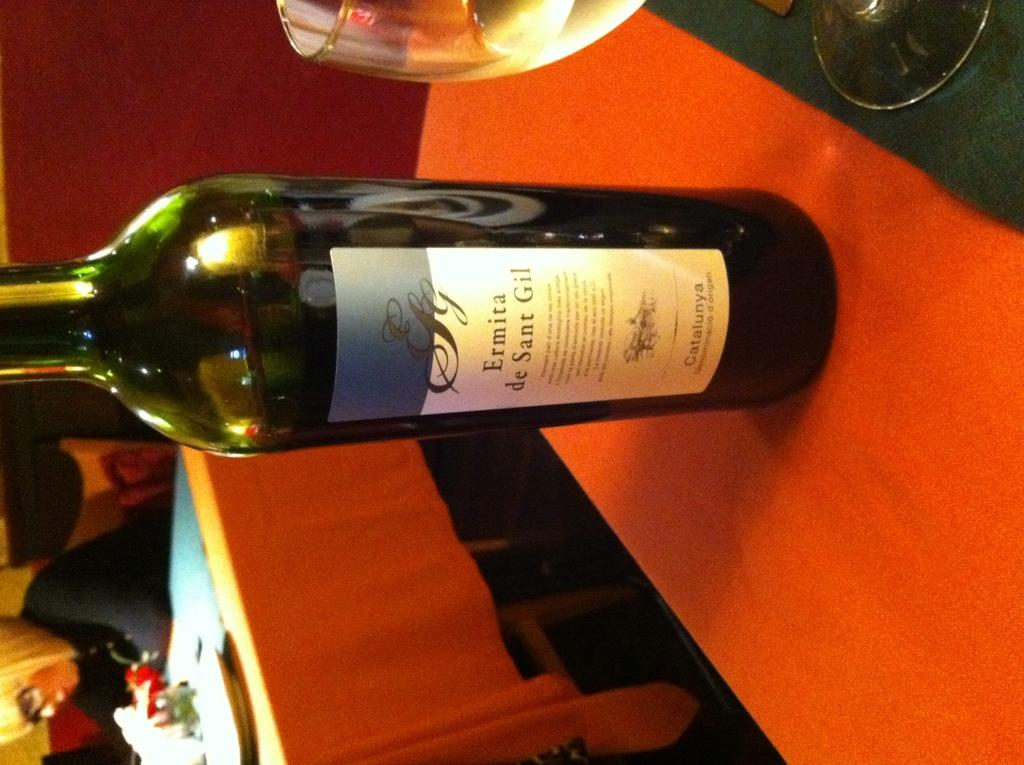<image>
Give a short and clear explanation of the subsequent image. A bottle of Ermita wine on a table. 